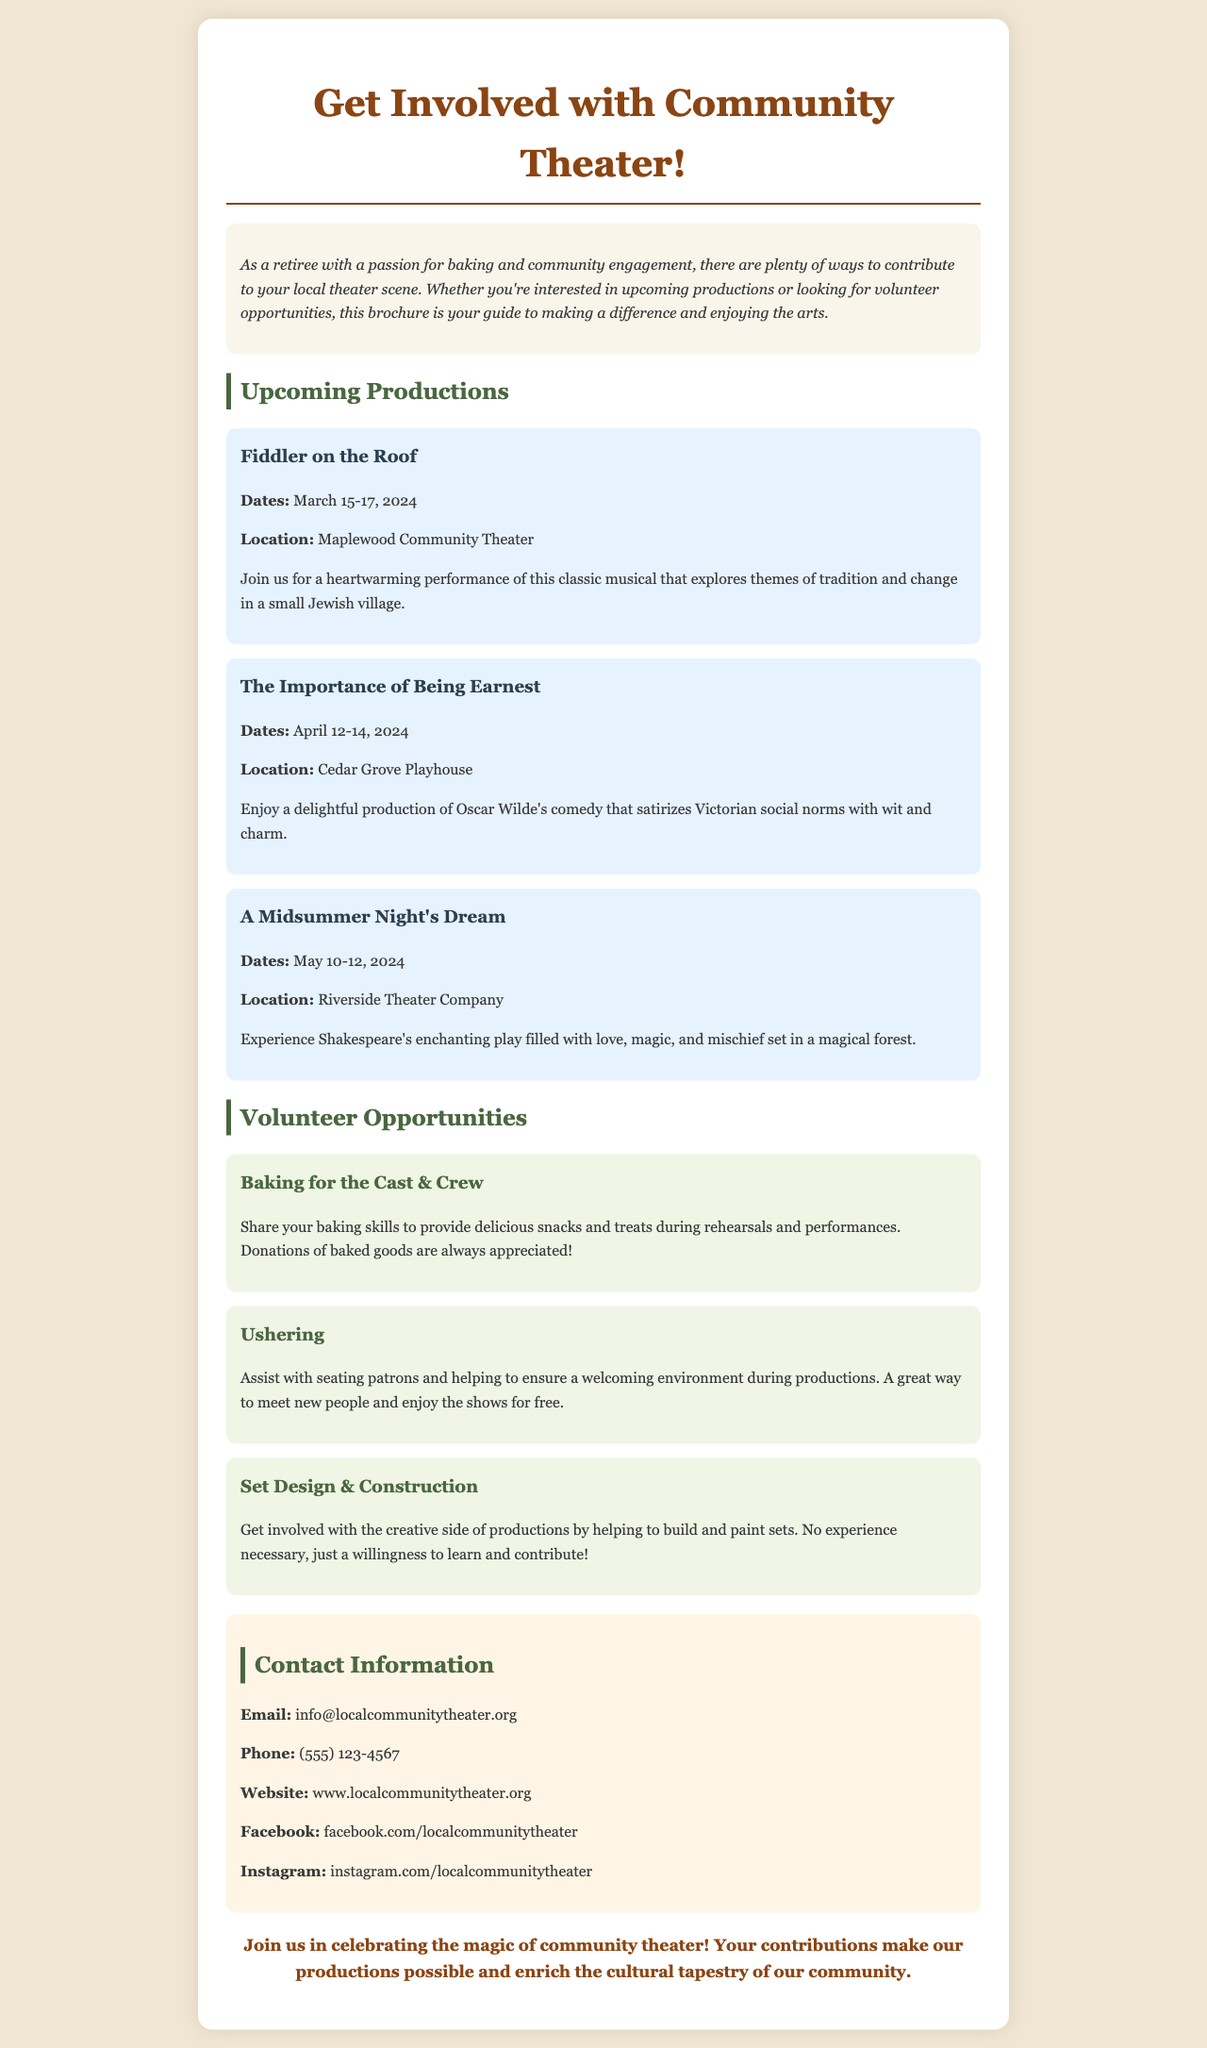what is the title of the first production? The first production mentioned is "Fiddler on the Roof."
Answer: Fiddler on the Roof what are the dates for "The Importance of Being Earnest"? The dates for this production are April 12-14, 2024.
Answer: April 12-14, 2024 where will "A Midsummer Night's Dream" be performed? The location of this performance is Riverside Theater Company.
Answer: Riverside Theater Company what is one way to volunteer at the theater? One way to volunteer is by baking for the cast & crew.
Answer: Baking for the Cast & Crew how can I contact the theater by phone? The phone number provided for contact is (555) 123-4567.
Answer: (555) 123-4567 which production explores themes of tradition and change? "Fiddler on the Roof" explores themes of tradition and change.
Answer: Fiddler on the Roof what type of volunteering involves working with sets? The type of volunteering that involves working with sets is Set Design & Construction.
Answer: Set Design & Construction what is the website for the local community theater? The website for the local community theater is www.localcommunitytheater.org.
Answer: www.localcommunitytheater.org 